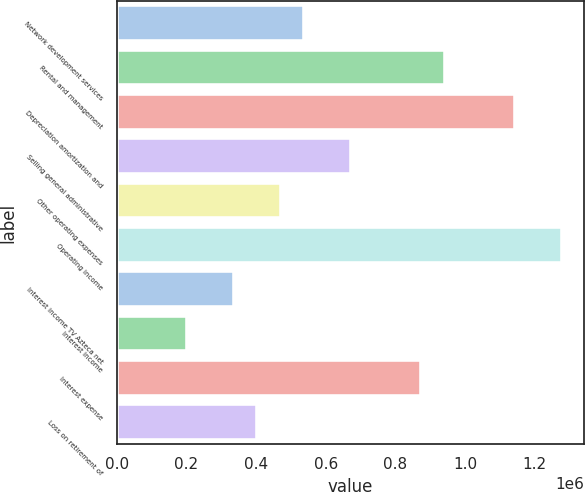<chart> <loc_0><loc_0><loc_500><loc_500><bar_chart><fcel>Network development services<fcel>Rental and management<fcel>Depreciation amortization and<fcel>Selling general administrative<fcel>Other operating expenses<fcel>Operating income<fcel>Interest income TV Azteca net<fcel>Interest income<fcel>Interest expense<fcel>Loss on retirement of<nl><fcel>537812<fcel>941151<fcel>1.14282e+06<fcel>672258<fcel>470588<fcel>1.27727e+06<fcel>336142<fcel>201696<fcel>873928<fcel>403365<nl></chart> 